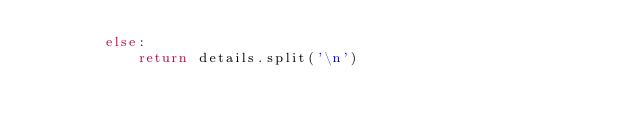Convert code to text. <code><loc_0><loc_0><loc_500><loc_500><_Python_>        else:
            return details.split('\n')
</code> 